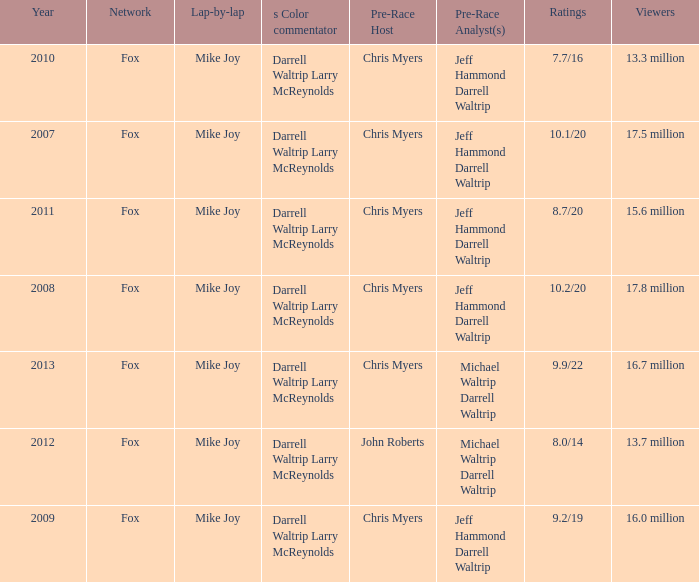Which Network has 17.5 million Viewers? Fox. 